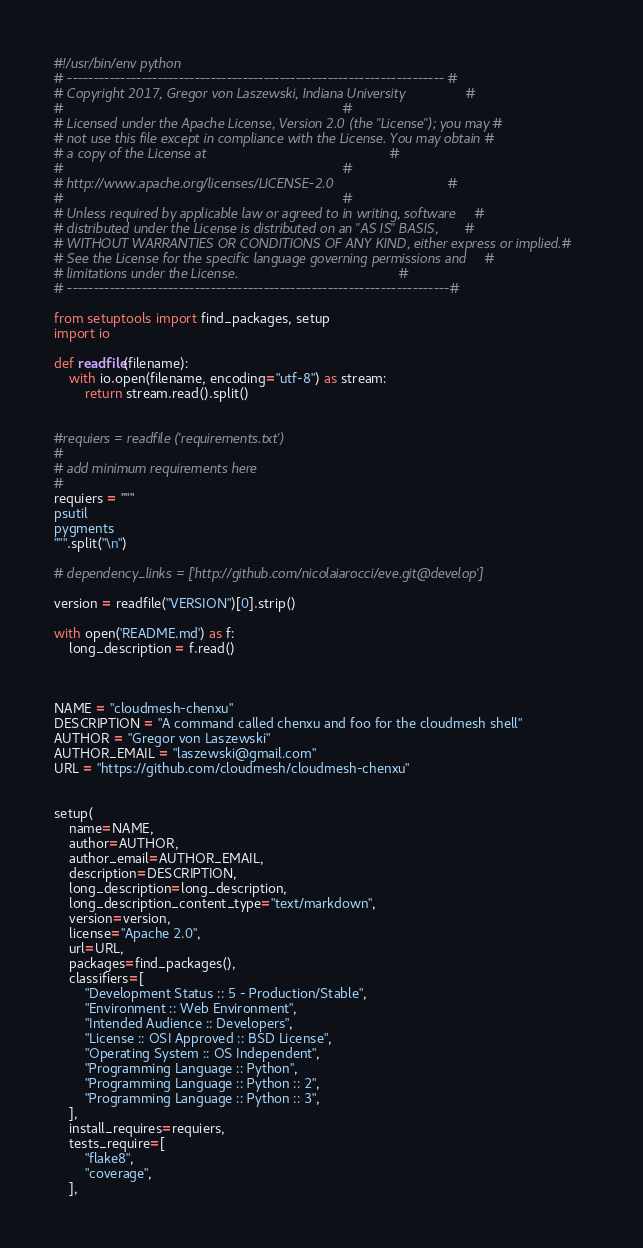<code> <loc_0><loc_0><loc_500><loc_500><_Python_>#!/usr/bin/env python
# ----------------------------------------------------------------------- #
# Copyright 2017, Gregor von Laszewski, Indiana University                #
#                                                                         #
# Licensed under the Apache License, Version 2.0 (the "License"); you may #
# not use this file except in compliance with the License. You may obtain #
# a copy of the License at                                                #
#                                                                         #
# http://www.apache.org/licenses/LICENSE-2.0                              #
#                                                                         #
# Unless required by applicable law or agreed to in writing, software     #
# distributed under the License is distributed on an "AS IS" BASIS,       #
# WITHOUT WARRANTIES OR CONDITIONS OF ANY KIND, either express or implied.#
# See the License for the specific language governing permissions and     #
# limitations under the License.                                          #
# ------------------------------------------------------------------------#

from setuptools import find_packages, setup
import io

def readfile(filename):
    with io.open(filename, encoding="utf-8") as stream:
        return stream.read().split()


#requiers = readfile ('requirements.txt')
#
# add minimum requirements here
#
requiers = """
psutil
pygments
""".split("\n")

# dependency_links = ['http://github.com/nicolaiarocci/eve.git@develop']

version = readfile("VERSION")[0].strip()

with open('README.md') as f:
    long_description = f.read()



NAME = "cloudmesh-chenxu"
DESCRIPTION = "A command called chenxu and foo for the cloudmesh shell"
AUTHOR = "Gregor von Laszewski"
AUTHOR_EMAIL = "laszewski@gmail.com"
URL = "https://github.com/cloudmesh/cloudmesh-chenxu"


setup(
    name=NAME,
    author=AUTHOR,
    author_email=AUTHOR_EMAIL,
    description=DESCRIPTION,
    long_description=long_description,
    long_description_content_type="text/markdown",
    version=version,
    license="Apache 2.0",
    url=URL,
    packages=find_packages(),
    classifiers=[
        "Development Status :: 5 - Production/Stable",
        "Environment :: Web Environment",
        "Intended Audience :: Developers",
        "License :: OSI Approved :: BSD License",
        "Operating System :: OS Independent",
        "Programming Language :: Python",
        "Programming Language :: Python :: 2",
        "Programming Language :: Python :: 3",
    ],
    install_requires=requiers,
    tests_require=[
        "flake8",
        "coverage",
    ],</code> 